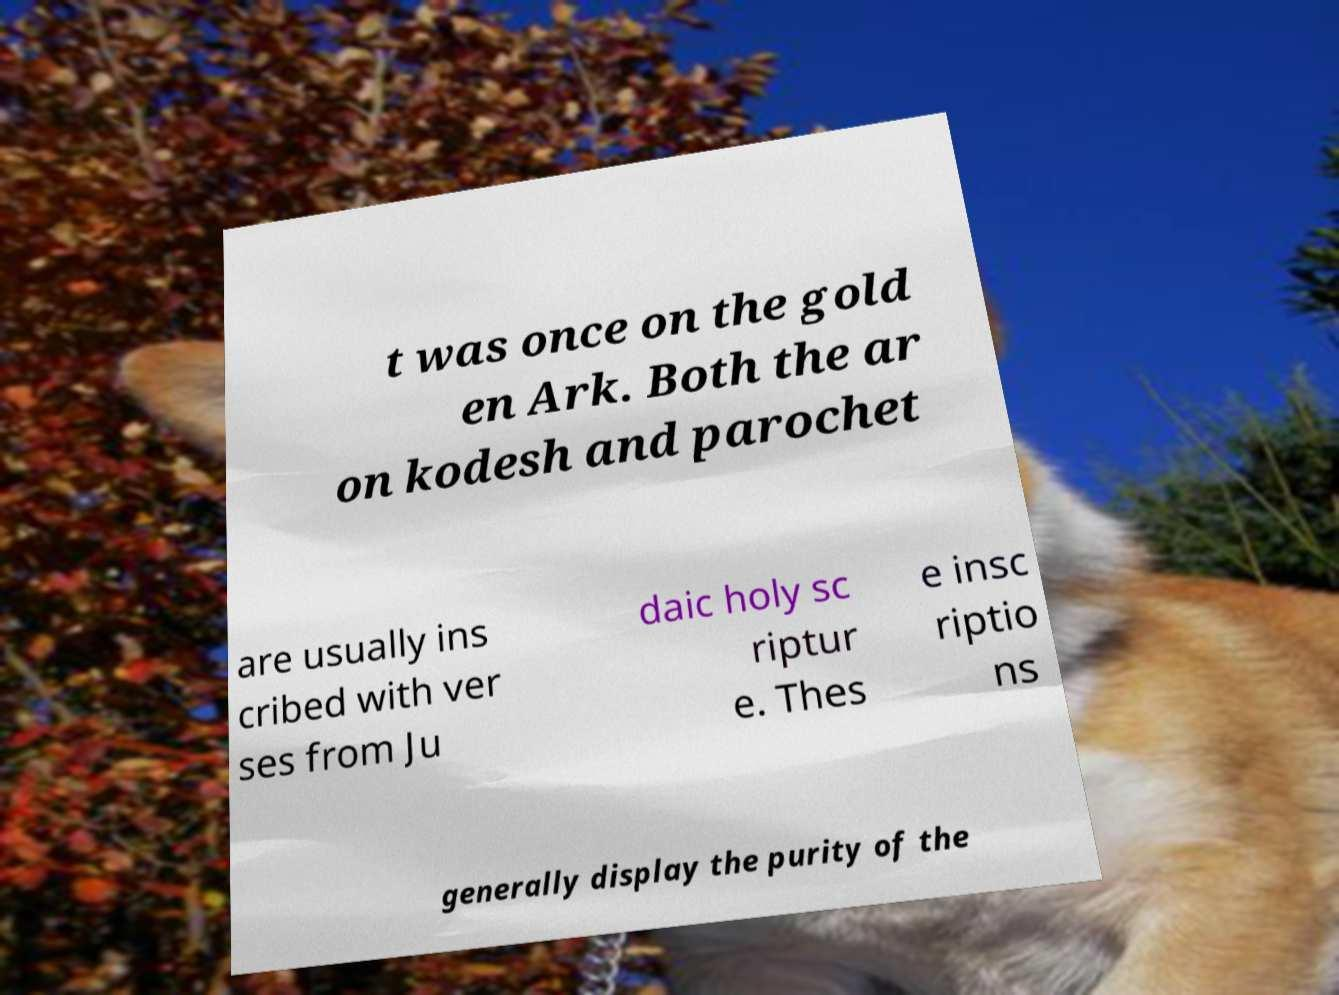Please identify and transcribe the text found in this image. t was once on the gold en Ark. Both the ar on kodesh and parochet are usually ins cribed with ver ses from Ju daic holy sc riptur e. Thes e insc riptio ns generally display the purity of the 